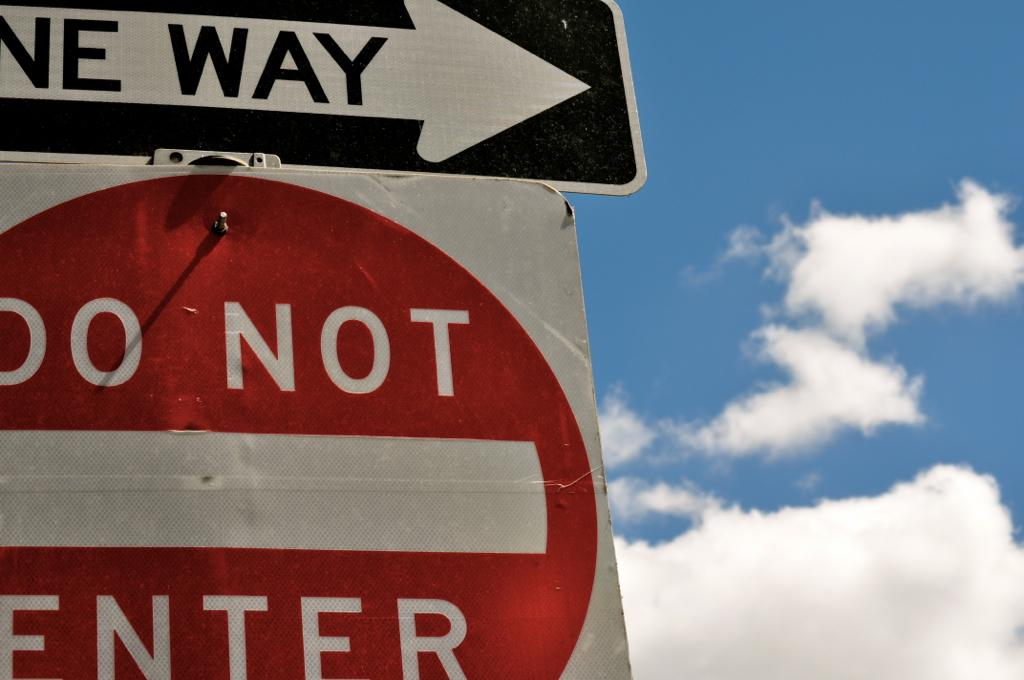<image>
Describe the image concisely. One sign says one way, the other says do not enter. 